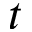<formula> <loc_0><loc_0><loc_500><loc_500>t</formula> 